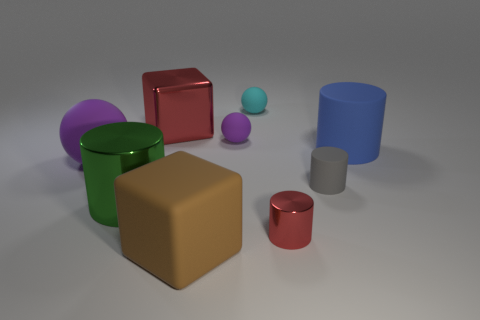What size is the red metallic cylinder?
Your response must be concise. Small. Is the number of tiny purple objects on the left side of the large ball less than the number of small gray rubber cylinders?
Your answer should be compact. Yes. Is the size of the brown cube the same as the blue matte object?
Your response must be concise. Yes. What color is the small thing that is the same material as the large red cube?
Your answer should be compact. Red. Is the number of tiny rubber objects that are to the right of the cyan object less than the number of big purple spheres in front of the rubber cube?
Your answer should be compact. No. What number of shiny objects have the same color as the large ball?
Your response must be concise. 0. There is a big object that is the same color as the tiny metal cylinder; what is it made of?
Provide a succinct answer. Metal. How many big objects are both behind the tiny gray object and in front of the small purple object?
Offer a terse response. 2. What is the material of the cylinder left of the shiny object that is on the right side of the big metallic block?
Offer a terse response. Metal. Are there any large cubes made of the same material as the large green object?
Your answer should be very brief. Yes. 